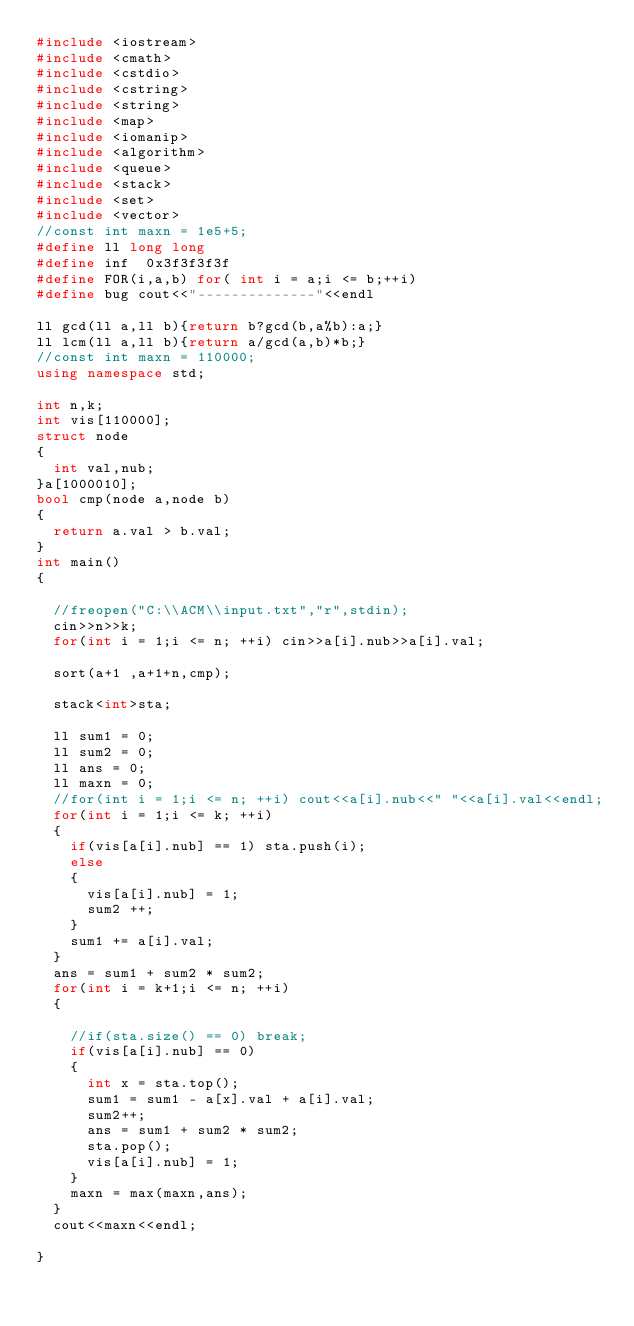<code> <loc_0><loc_0><loc_500><loc_500><_C++_>#include <iostream>
#include <cmath>
#include <cstdio>
#include <cstring>
#include <string>
#include <map>
#include <iomanip>
#include <algorithm>
#include <queue>
#include <stack>
#include <set>
#include <vector>
//const int maxn = 1e5+5;
#define ll long long
#define inf  0x3f3f3f3f
#define FOR(i,a,b) for( int i = a;i <= b;++i)
#define bug cout<<"--------------"<<endl

ll gcd(ll a,ll b){return b?gcd(b,a%b):a;}
ll lcm(ll a,ll b){return a/gcd(a,b)*b;}
//const int maxn = 110000;
using namespace std;

int n,k;
int vis[110000];
struct node 
{
	int val,nub;
}a[1000010];
bool cmp(node a,node b)
{
	return a.val > b.val;
}
int main()
{

	//freopen("C:\\ACM\\input.txt","r",stdin);
	cin>>n>>k;
	for(int i = 1;i <= n; ++i) cin>>a[i].nub>>a[i].val;

	sort(a+1 ,a+1+n,cmp);
	
	stack<int>sta;

	ll sum1 = 0;
	ll sum2 = 0;
	ll ans = 0;
	ll maxn = 0;
	//for(int i = 1;i <= n; ++i) cout<<a[i].nub<<" "<<a[i].val<<endl;
	for(int i = 1;i <= k; ++i)
	{
		if(vis[a[i].nub] == 1) sta.push(i);
		else 
		{
			vis[a[i].nub] = 1;
			sum2 ++;
		}
		sum1 += a[i].val;
	}
	ans = sum1 + sum2 * sum2;
	for(int i = k+1;i <= n; ++i)
	{
		
		//if(sta.size() == 0) break;
		if(vis[a[i].nub] == 0)
		{
			int x = sta.top();
			sum1 = sum1 - a[x].val + a[i].val;
			sum2++;
			ans = sum1 + sum2 * sum2;
			sta.pop();
			vis[a[i].nub] = 1;
		}
		maxn = max(maxn,ans);
	}
	cout<<maxn<<endl;

}</code> 